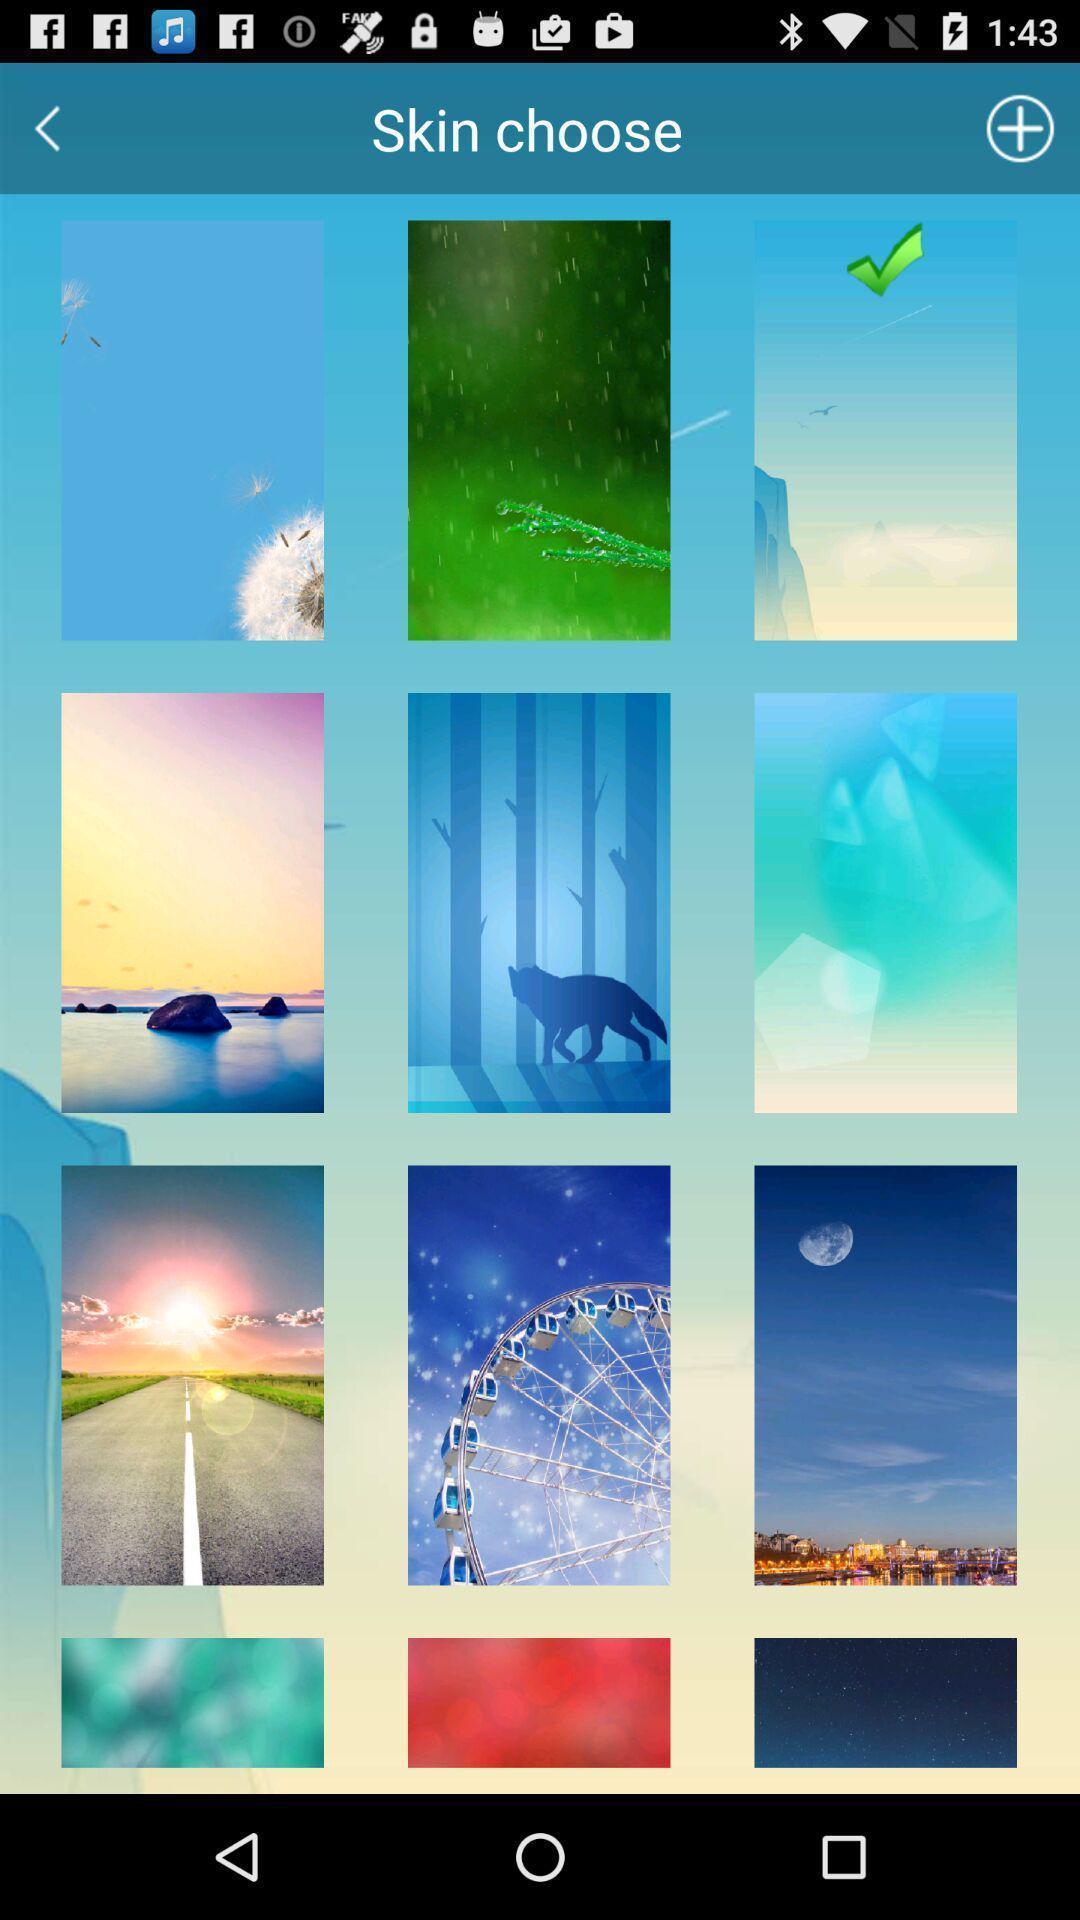Describe the content in this image. Screen asking to skin choose a wall paper. 